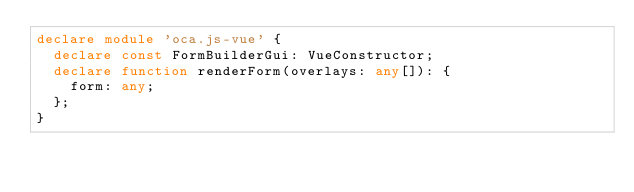<code> <loc_0><loc_0><loc_500><loc_500><_TypeScript_>declare module 'oca.js-vue' {
  declare const FormBuilderGui: VueConstructor;
  declare function renderForm(overlays: any[]): {
    form: any;
  };
}</code> 